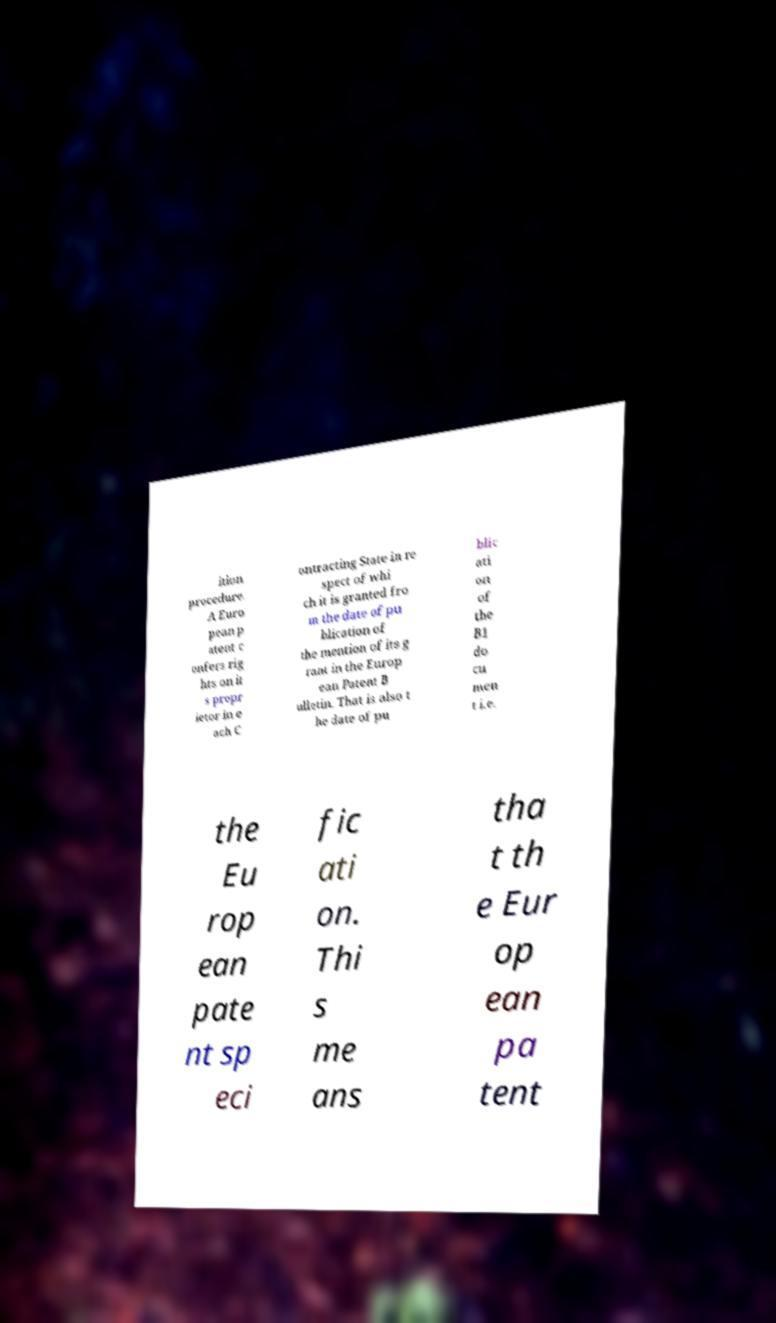Can you read and provide the text displayed in the image?This photo seems to have some interesting text. Can you extract and type it out for me? ition procedure. A Euro pean p atent c onfers rig hts on it s propr ietor in e ach C ontracting State in re spect of whi ch it is granted fro m the date of pu blication of the mention of its g rant in the Europ ean Patent B ulletin. That is also t he date of pu blic ati on of the B1 do cu men t i.e. the Eu rop ean pate nt sp eci fic ati on. Thi s me ans tha t th e Eur op ean pa tent 